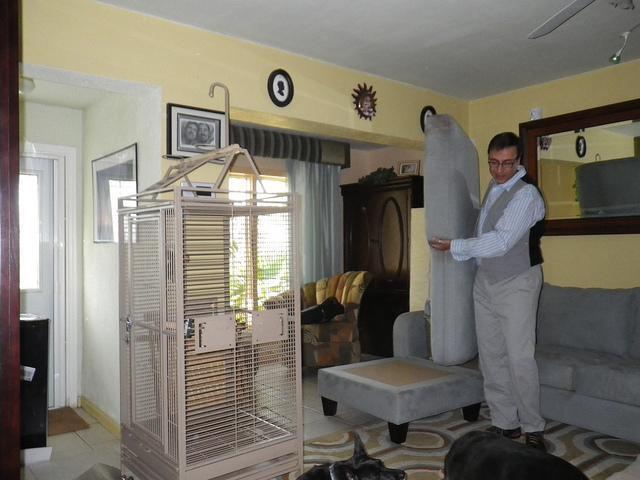Pet care Helpline number?
Indicate the correct response and explain using: 'Answer: answer
Rationale: rationale.'
Options: 966, 952, 822, 911. Answer: 952.
Rationale: This is common knowledge that 952 is the pet helpline number. 